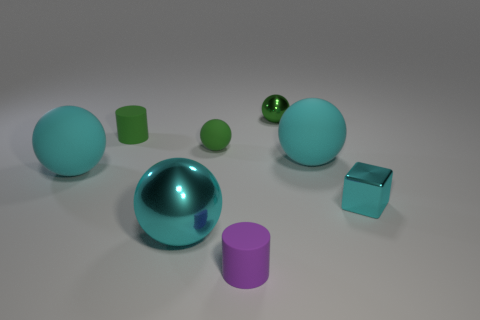What is the material of the tiny cylinder that is the same color as the small matte ball?
Ensure brevity in your answer.  Rubber. There is a shiny object that is the same color as the tiny metallic block; what is its size?
Your answer should be compact. Large. There is a cyan thing that is made of the same material as the small cube; what is its shape?
Your response must be concise. Sphere. Are there any other things that have the same color as the small matte ball?
Your response must be concise. Yes. How many big green things are there?
Your answer should be compact. 0. What material is the small sphere to the right of the small rubber cylinder that is in front of the big cyan metal thing?
Your answer should be very brief. Metal. What is the color of the big thing that is left of the shiny thing left of the small green ball behind the small green rubber cylinder?
Keep it short and to the point. Cyan. Is the large shiny thing the same color as the metallic cube?
Give a very brief answer. Yes. What number of cyan metallic spheres have the same size as the green metallic sphere?
Give a very brief answer. 0. Are there more small rubber things that are on the left side of the tiny matte sphere than large metallic spheres that are right of the tiny purple rubber cylinder?
Provide a succinct answer. Yes. 